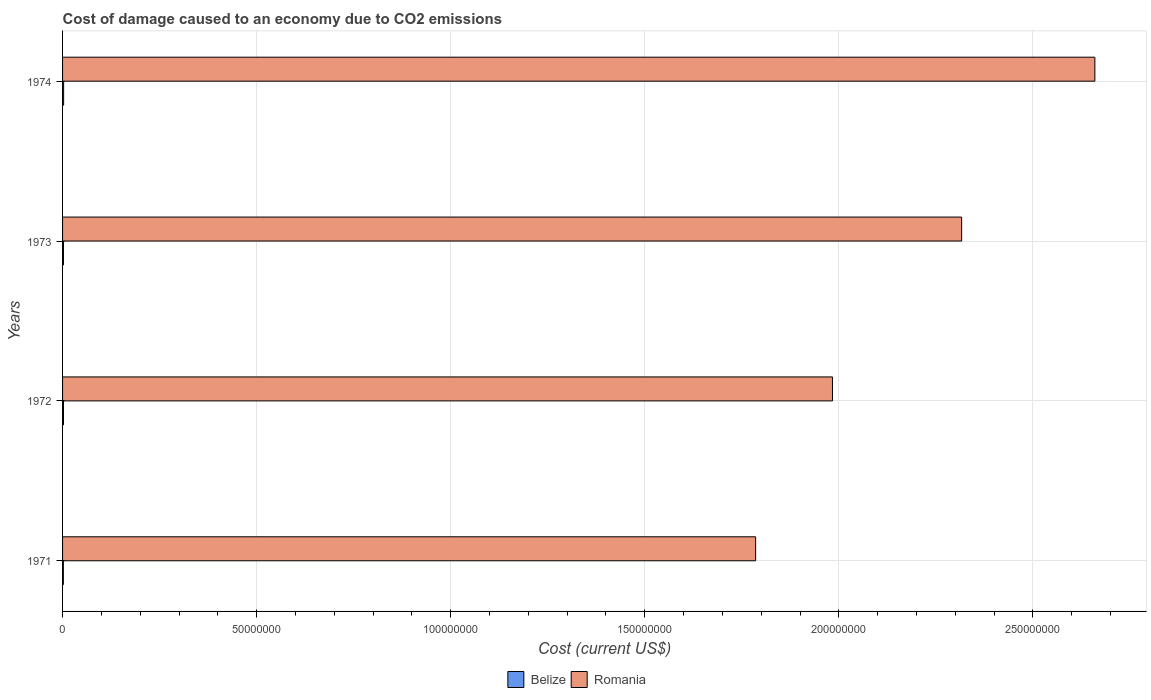How many groups of bars are there?
Make the answer very short. 4. Are the number of bars on each tick of the Y-axis equal?
Your answer should be compact. Yes. What is the label of the 1st group of bars from the top?
Offer a terse response. 1974. In how many cases, is the number of bars for a given year not equal to the number of legend labels?
Provide a succinct answer. 0. What is the cost of damage caused due to CO2 emissisons in Romania in 1972?
Your answer should be very brief. 1.98e+08. Across all years, what is the maximum cost of damage caused due to CO2 emissisons in Romania?
Make the answer very short. 2.66e+08. Across all years, what is the minimum cost of damage caused due to CO2 emissisons in Belize?
Your response must be concise. 2.03e+05. In which year was the cost of damage caused due to CO2 emissisons in Belize maximum?
Offer a terse response. 1974. What is the total cost of damage caused due to CO2 emissisons in Belize in the graph?
Give a very brief answer. 9.45e+05. What is the difference between the cost of damage caused due to CO2 emissisons in Belize in 1971 and that in 1973?
Give a very brief answer. -3.14e+04. What is the difference between the cost of damage caused due to CO2 emissisons in Belize in 1973 and the cost of damage caused due to CO2 emissisons in Romania in 1974?
Provide a short and direct response. -2.66e+08. What is the average cost of damage caused due to CO2 emissisons in Belize per year?
Keep it short and to the point. 2.36e+05. In the year 1974, what is the difference between the cost of damage caused due to CO2 emissisons in Belize and cost of damage caused due to CO2 emissisons in Romania?
Your response must be concise. -2.66e+08. In how many years, is the cost of damage caused due to CO2 emissisons in Belize greater than 40000000 US$?
Offer a terse response. 0. What is the ratio of the cost of damage caused due to CO2 emissisons in Belize in 1971 to that in 1973?
Your response must be concise. 0.87. What is the difference between the highest and the second highest cost of damage caused due to CO2 emissisons in Romania?
Provide a short and direct response. 3.43e+07. What is the difference between the highest and the lowest cost of damage caused due to CO2 emissisons in Belize?
Offer a very short reply. 6.84e+04. In how many years, is the cost of damage caused due to CO2 emissisons in Romania greater than the average cost of damage caused due to CO2 emissisons in Romania taken over all years?
Offer a very short reply. 2. What does the 2nd bar from the top in 1972 represents?
Your answer should be very brief. Belize. What does the 1st bar from the bottom in 1972 represents?
Provide a succinct answer. Belize. How many years are there in the graph?
Provide a short and direct response. 4. What is the difference between two consecutive major ticks on the X-axis?
Offer a terse response. 5.00e+07. Does the graph contain grids?
Give a very brief answer. Yes. How many legend labels are there?
Provide a succinct answer. 2. How are the legend labels stacked?
Keep it short and to the point. Horizontal. What is the title of the graph?
Ensure brevity in your answer.  Cost of damage caused to an economy due to CO2 emissions. Does "Iraq" appear as one of the legend labels in the graph?
Offer a terse response. No. What is the label or title of the X-axis?
Keep it short and to the point. Cost (current US$). What is the label or title of the Y-axis?
Offer a very short reply. Years. What is the Cost (current US$) of Belize in 1971?
Your answer should be very brief. 2.03e+05. What is the Cost (current US$) in Romania in 1971?
Your response must be concise. 1.79e+08. What is the Cost (current US$) in Belize in 1972?
Provide a succinct answer. 2.36e+05. What is the Cost (current US$) in Romania in 1972?
Your response must be concise. 1.98e+08. What is the Cost (current US$) of Belize in 1973?
Give a very brief answer. 2.34e+05. What is the Cost (current US$) in Romania in 1973?
Your answer should be compact. 2.32e+08. What is the Cost (current US$) in Belize in 1974?
Provide a short and direct response. 2.71e+05. What is the Cost (current US$) in Romania in 1974?
Offer a very short reply. 2.66e+08. Across all years, what is the maximum Cost (current US$) in Belize?
Provide a short and direct response. 2.71e+05. Across all years, what is the maximum Cost (current US$) in Romania?
Ensure brevity in your answer.  2.66e+08. Across all years, what is the minimum Cost (current US$) in Belize?
Give a very brief answer. 2.03e+05. Across all years, what is the minimum Cost (current US$) in Romania?
Offer a very short reply. 1.79e+08. What is the total Cost (current US$) in Belize in the graph?
Provide a short and direct response. 9.45e+05. What is the total Cost (current US$) in Romania in the graph?
Make the answer very short. 8.75e+08. What is the difference between the Cost (current US$) of Belize in 1971 and that in 1972?
Your answer should be compact. -3.32e+04. What is the difference between the Cost (current US$) in Romania in 1971 and that in 1972?
Make the answer very short. -1.98e+07. What is the difference between the Cost (current US$) of Belize in 1971 and that in 1973?
Make the answer very short. -3.14e+04. What is the difference between the Cost (current US$) of Romania in 1971 and that in 1973?
Your response must be concise. -5.31e+07. What is the difference between the Cost (current US$) of Belize in 1971 and that in 1974?
Give a very brief answer. -6.84e+04. What is the difference between the Cost (current US$) of Romania in 1971 and that in 1974?
Your answer should be compact. -8.74e+07. What is the difference between the Cost (current US$) in Belize in 1972 and that in 1973?
Make the answer very short. 1800.89. What is the difference between the Cost (current US$) in Romania in 1972 and that in 1973?
Your answer should be very brief. -3.33e+07. What is the difference between the Cost (current US$) of Belize in 1972 and that in 1974?
Give a very brief answer. -3.52e+04. What is the difference between the Cost (current US$) in Romania in 1972 and that in 1974?
Keep it short and to the point. -6.76e+07. What is the difference between the Cost (current US$) of Belize in 1973 and that in 1974?
Provide a succinct answer. -3.70e+04. What is the difference between the Cost (current US$) in Romania in 1973 and that in 1974?
Offer a terse response. -3.43e+07. What is the difference between the Cost (current US$) of Belize in 1971 and the Cost (current US$) of Romania in 1972?
Offer a very short reply. -1.98e+08. What is the difference between the Cost (current US$) in Belize in 1971 and the Cost (current US$) in Romania in 1973?
Provide a succinct answer. -2.31e+08. What is the difference between the Cost (current US$) of Belize in 1971 and the Cost (current US$) of Romania in 1974?
Provide a short and direct response. -2.66e+08. What is the difference between the Cost (current US$) of Belize in 1972 and the Cost (current US$) of Romania in 1973?
Your answer should be compact. -2.31e+08. What is the difference between the Cost (current US$) of Belize in 1972 and the Cost (current US$) of Romania in 1974?
Your response must be concise. -2.66e+08. What is the difference between the Cost (current US$) of Belize in 1973 and the Cost (current US$) of Romania in 1974?
Ensure brevity in your answer.  -2.66e+08. What is the average Cost (current US$) of Belize per year?
Offer a terse response. 2.36e+05. What is the average Cost (current US$) of Romania per year?
Ensure brevity in your answer.  2.19e+08. In the year 1971, what is the difference between the Cost (current US$) of Belize and Cost (current US$) of Romania?
Give a very brief answer. -1.78e+08. In the year 1972, what is the difference between the Cost (current US$) in Belize and Cost (current US$) in Romania?
Provide a succinct answer. -1.98e+08. In the year 1973, what is the difference between the Cost (current US$) in Belize and Cost (current US$) in Romania?
Your answer should be very brief. -2.31e+08. In the year 1974, what is the difference between the Cost (current US$) in Belize and Cost (current US$) in Romania?
Offer a terse response. -2.66e+08. What is the ratio of the Cost (current US$) in Belize in 1971 to that in 1972?
Offer a terse response. 0.86. What is the ratio of the Cost (current US$) in Romania in 1971 to that in 1972?
Keep it short and to the point. 0.9. What is the ratio of the Cost (current US$) in Belize in 1971 to that in 1973?
Give a very brief answer. 0.87. What is the ratio of the Cost (current US$) of Romania in 1971 to that in 1973?
Your response must be concise. 0.77. What is the ratio of the Cost (current US$) of Belize in 1971 to that in 1974?
Provide a short and direct response. 0.75. What is the ratio of the Cost (current US$) in Romania in 1971 to that in 1974?
Ensure brevity in your answer.  0.67. What is the ratio of the Cost (current US$) in Belize in 1972 to that in 1973?
Offer a very short reply. 1.01. What is the ratio of the Cost (current US$) in Romania in 1972 to that in 1973?
Make the answer very short. 0.86. What is the ratio of the Cost (current US$) of Belize in 1972 to that in 1974?
Make the answer very short. 0.87. What is the ratio of the Cost (current US$) in Romania in 1972 to that in 1974?
Give a very brief answer. 0.75. What is the ratio of the Cost (current US$) of Belize in 1973 to that in 1974?
Keep it short and to the point. 0.86. What is the ratio of the Cost (current US$) in Romania in 1973 to that in 1974?
Provide a succinct answer. 0.87. What is the difference between the highest and the second highest Cost (current US$) in Belize?
Your answer should be very brief. 3.52e+04. What is the difference between the highest and the second highest Cost (current US$) of Romania?
Your response must be concise. 3.43e+07. What is the difference between the highest and the lowest Cost (current US$) in Belize?
Provide a short and direct response. 6.84e+04. What is the difference between the highest and the lowest Cost (current US$) of Romania?
Offer a very short reply. 8.74e+07. 